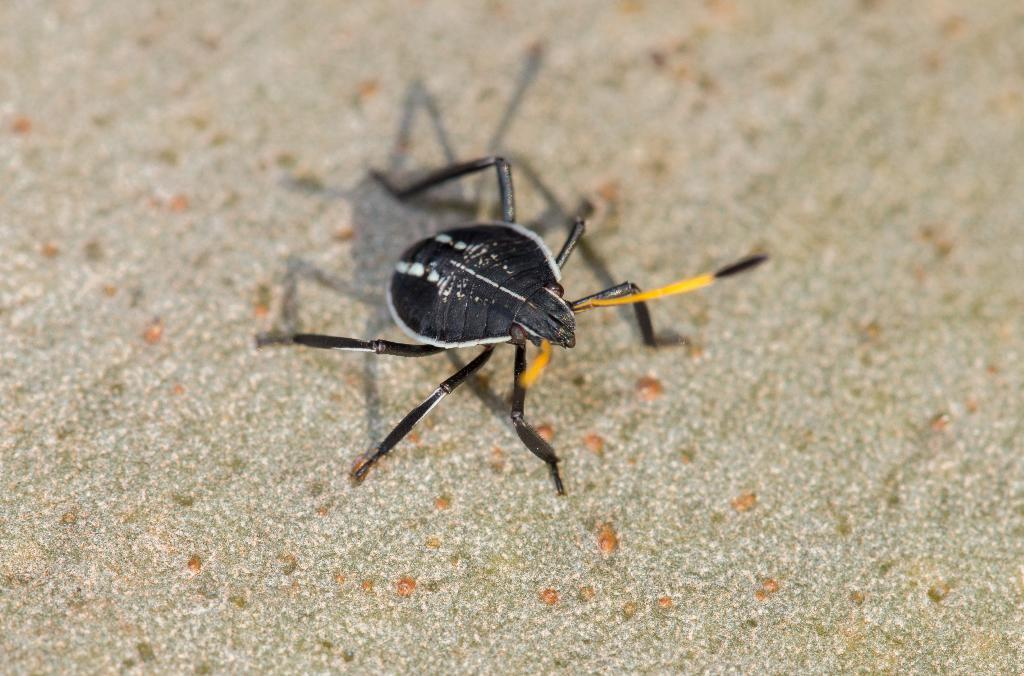What type of creature can be seen in the image? There is an insect in the image. Where is the insect located in the image? The insect is located in the center of the image. What type of writing can be seen on the library wall in the image? There is no library or writing present in the image; it features an insect in the center. What is the insect using to hammer a nail in the image? Insects do not have the ability to use hammers, and there is no hammer present in the image. 